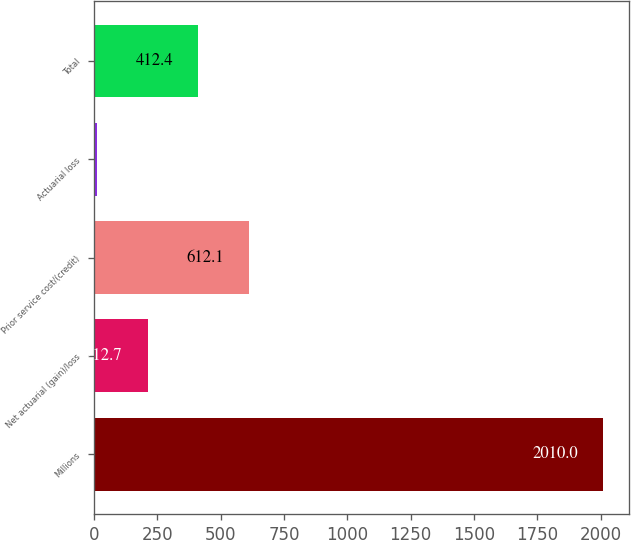Convert chart. <chart><loc_0><loc_0><loc_500><loc_500><bar_chart><fcel>Millions<fcel>Net actuarial (gain)/loss<fcel>Prior service cost/(credit)<fcel>Actuarial loss<fcel>Total<nl><fcel>2010<fcel>212.7<fcel>612.1<fcel>13<fcel>412.4<nl></chart> 